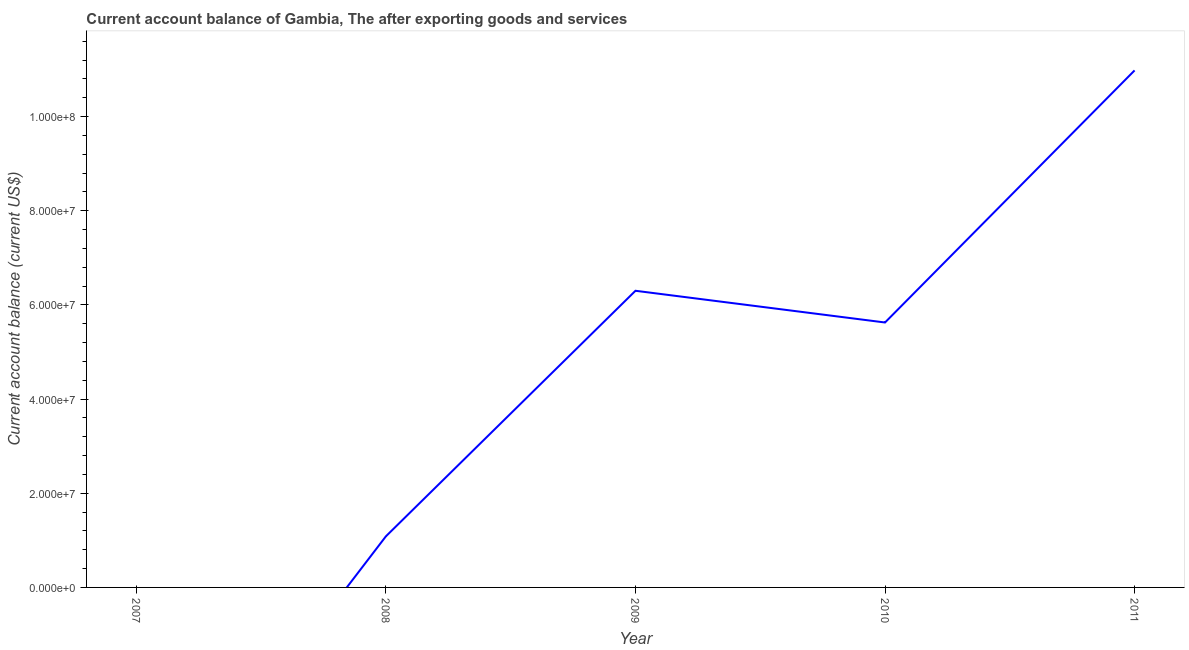What is the current account balance in 2008?
Offer a very short reply. 1.09e+07. Across all years, what is the maximum current account balance?
Make the answer very short. 1.10e+08. In which year was the current account balance maximum?
Your response must be concise. 2011. What is the sum of the current account balance?
Your answer should be compact. 2.40e+08. What is the difference between the current account balance in 2009 and 2011?
Offer a terse response. -4.68e+07. What is the average current account balance per year?
Your answer should be very brief. 4.80e+07. What is the median current account balance?
Keep it short and to the point. 5.63e+07. What is the ratio of the current account balance in 2009 to that in 2011?
Make the answer very short. 0.57. Is the current account balance in 2009 less than that in 2010?
Your response must be concise. No. Is the difference between the current account balance in 2010 and 2011 greater than the difference between any two years?
Your answer should be very brief. No. What is the difference between the highest and the second highest current account balance?
Provide a succinct answer. 4.68e+07. Is the sum of the current account balance in 2009 and 2010 greater than the maximum current account balance across all years?
Make the answer very short. Yes. What is the difference between the highest and the lowest current account balance?
Offer a terse response. 1.10e+08. Does the current account balance monotonically increase over the years?
Offer a very short reply. No. How many lines are there?
Your answer should be compact. 1. How many years are there in the graph?
Provide a short and direct response. 5. What is the difference between two consecutive major ticks on the Y-axis?
Your answer should be very brief. 2.00e+07. Does the graph contain any zero values?
Provide a succinct answer. Yes. What is the title of the graph?
Keep it short and to the point. Current account balance of Gambia, The after exporting goods and services. What is the label or title of the X-axis?
Provide a short and direct response. Year. What is the label or title of the Y-axis?
Your response must be concise. Current account balance (current US$). What is the Current account balance (current US$) in 2007?
Your response must be concise. 0. What is the Current account balance (current US$) in 2008?
Give a very brief answer. 1.09e+07. What is the Current account balance (current US$) in 2009?
Your response must be concise. 6.30e+07. What is the Current account balance (current US$) in 2010?
Keep it short and to the point. 5.63e+07. What is the Current account balance (current US$) of 2011?
Your answer should be very brief. 1.10e+08. What is the difference between the Current account balance (current US$) in 2008 and 2009?
Your answer should be very brief. -5.21e+07. What is the difference between the Current account balance (current US$) in 2008 and 2010?
Provide a short and direct response. -4.54e+07. What is the difference between the Current account balance (current US$) in 2008 and 2011?
Your answer should be very brief. -9.89e+07. What is the difference between the Current account balance (current US$) in 2009 and 2010?
Ensure brevity in your answer.  6.74e+06. What is the difference between the Current account balance (current US$) in 2009 and 2011?
Provide a short and direct response. -4.68e+07. What is the difference between the Current account balance (current US$) in 2010 and 2011?
Your answer should be compact. -5.35e+07. What is the ratio of the Current account balance (current US$) in 2008 to that in 2009?
Your answer should be compact. 0.17. What is the ratio of the Current account balance (current US$) in 2008 to that in 2010?
Your answer should be very brief. 0.19. What is the ratio of the Current account balance (current US$) in 2008 to that in 2011?
Offer a very short reply. 0.1. What is the ratio of the Current account balance (current US$) in 2009 to that in 2010?
Your answer should be very brief. 1.12. What is the ratio of the Current account balance (current US$) in 2009 to that in 2011?
Keep it short and to the point. 0.57. What is the ratio of the Current account balance (current US$) in 2010 to that in 2011?
Ensure brevity in your answer.  0.51. 